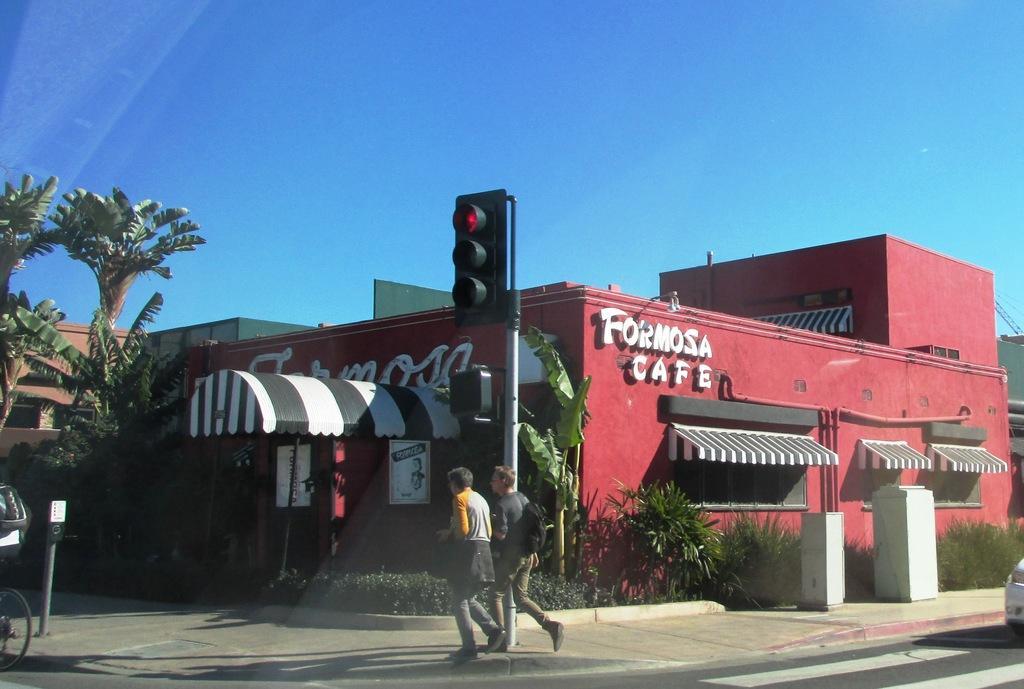Can you describe this image briefly? In this image there is the sky towards the top of the image, there is a building towards the right of the image, there is a building towards the left of the image, there is text on the building, there is a tree towards the left of the image, there are plants, there is a board on the building, there is text on the board, there is road towards the bottom of the image, there are two men walking, there is a man wearing a bag, there are poles, there is a traffic light, there is an object towards the right of the image that looks like a car, there is a bicycle wheel towards the left of the image, there is a person on the bicycle, he is wearing a bag. 